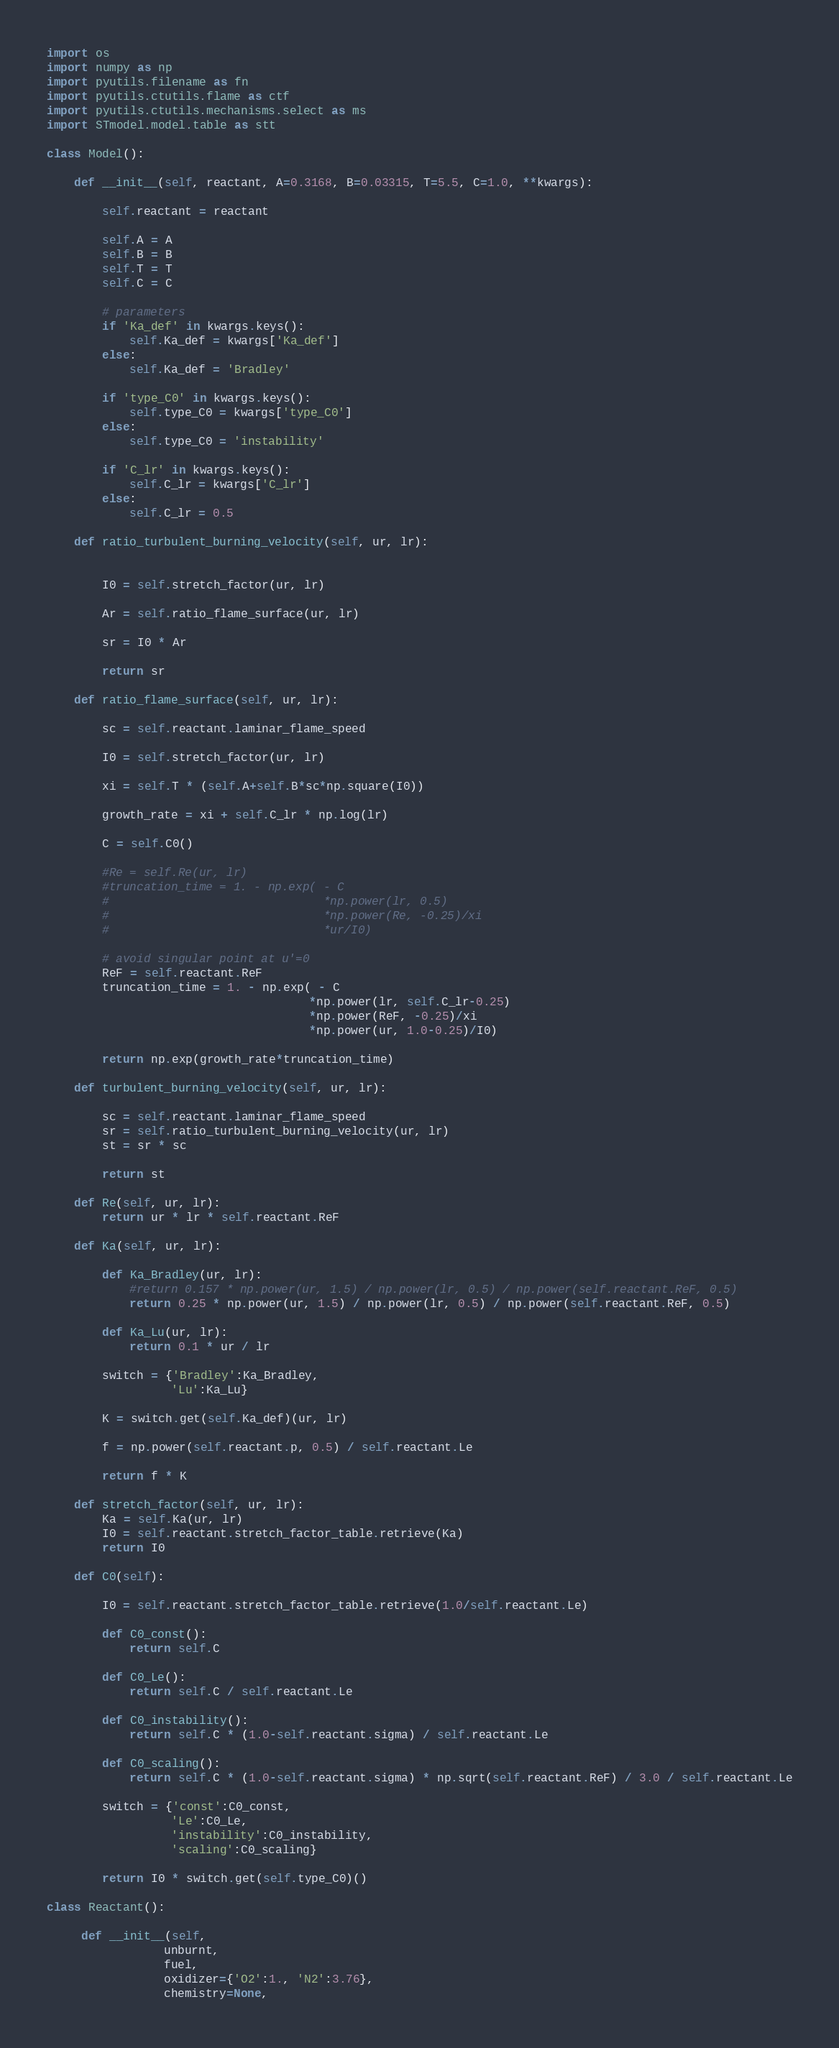<code> <loc_0><loc_0><loc_500><loc_500><_Python_>import os
import numpy as np
import pyutils.filename as fn
import pyutils.ctutils.flame as ctf
import pyutils.ctutils.mechanisms.select as ms
import STmodel.model.table as stt

class Model():
    
    def __init__(self, reactant, A=0.3168, B=0.03315, T=5.5, C=1.0, **kwargs):

        self.reactant = reactant

        self.A = A
        self.B = B
        self.T = T
        self.C = C

        # parameters
        if 'Ka_def' in kwargs.keys():
            self.Ka_def = kwargs['Ka_def']
        else:
            self.Ka_def = 'Bradley'

        if 'type_C0' in kwargs.keys():
            self.type_C0 = kwargs['type_C0']
        else:
            self.type_C0 = 'instability'

        if 'C_lr' in kwargs.keys():
            self.C_lr = kwargs['C_lr']
        else:
            self.C_lr = 0.5

    def ratio_turbulent_burning_velocity(self, ur, lr):


        I0 = self.stretch_factor(ur, lr)

        Ar = self.ratio_flame_surface(ur, lr)

        sr = I0 * Ar

        return sr

    def ratio_flame_surface(self, ur, lr):

        sc = self.reactant.laminar_flame_speed

        I0 = self.stretch_factor(ur, lr)

        xi = self.T * (self.A+self.B*sc*np.square(I0))

        growth_rate = xi + self.C_lr * np.log(lr)

        C = self.C0()

        #Re = self.Re(ur, lr)
        #truncation_time = 1. - np.exp( - C
        #                               *np.power(lr, 0.5)
        #                               *np.power(Re, -0.25)/xi
        #                               *ur/I0)

        # avoid singular point at u'=0
        ReF = self.reactant.ReF
        truncation_time = 1. - np.exp( - C
                                      *np.power(lr, self.C_lr-0.25)
                                      *np.power(ReF, -0.25)/xi
                                      *np.power(ur, 1.0-0.25)/I0)

        return np.exp(growth_rate*truncation_time)

    def turbulent_burning_velocity(self, ur, lr):

        sc = self.reactant.laminar_flame_speed
        sr = self.ratio_turbulent_burning_velocity(ur, lr)
        st = sr * sc

        return st

    def Re(self, ur, lr):
        return ur * lr * self.reactant.ReF

    def Ka(self, ur, lr):

        def Ka_Bradley(ur, lr):
            #return 0.157 * np.power(ur, 1.5) / np.power(lr, 0.5) / np.power(self.reactant.ReF, 0.5)
            return 0.25 * np.power(ur, 1.5) / np.power(lr, 0.5) / np.power(self.reactant.ReF, 0.5)

        def Ka_Lu(ur, lr):
            return 0.1 * ur / lr

        switch = {'Bradley':Ka_Bradley,
                  'Lu':Ka_Lu}

        K = switch.get(self.Ka_def)(ur, lr)
        
        f = np.power(self.reactant.p, 0.5) / self.reactant.Le

        return f * K

    def stretch_factor(self, ur, lr):
        Ka = self.Ka(ur, lr)
        I0 = self.reactant.stretch_factor_table.retrieve(Ka)
        return I0

    def C0(self):

        I0 = self.reactant.stretch_factor_table.retrieve(1.0/self.reactant.Le)

        def C0_const():
            return self.C

        def C0_Le():
            return self.C / self.reactant.Le

        def C0_instability():
            return self.C * (1.0-self.reactant.sigma) / self.reactant.Le

        def C0_scaling():
            return self.C * (1.0-self.reactant.sigma) * np.sqrt(self.reactant.ReF) / 3.0 / self.reactant.Le

        switch = {'const':C0_const,
                  'Le':C0_Le,
                  'instability':C0_instability,
                  'scaling':C0_scaling}

        return I0 * switch.get(self.type_C0)()

class Reactant():

     def __init__(self, 
                 unburnt, 
                 fuel, 
                 oxidizer={'O2':1., 'N2':3.76}, 
                 chemistry=None, </code> 